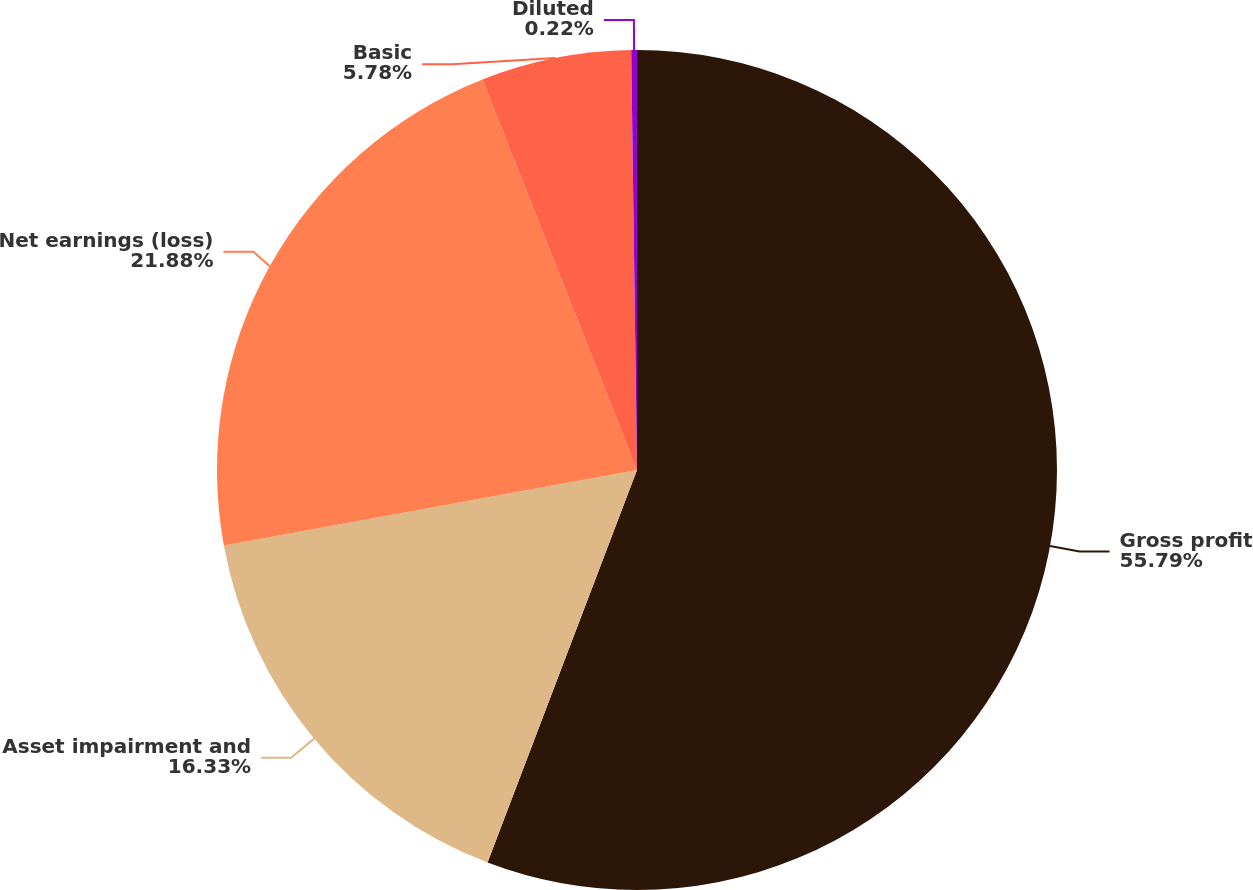Convert chart. <chart><loc_0><loc_0><loc_500><loc_500><pie_chart><fcel>Gross profit<fcel>Asset impairment and<fcel>Net earnings (loss)<fcel>Basic<fcel>Diluted<nl><fcel>55.79%<fcel>16.33%<fcel>21.88%<fcel>5.78%<fcel>0.22%<nl></chart> 